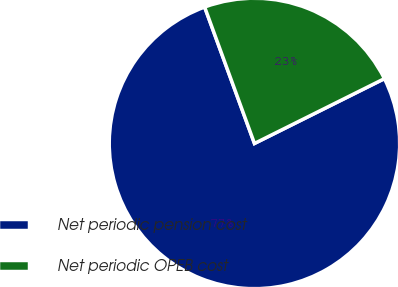Convert chart to OTSL. <chart><loc_0><loc_0><loc_500><loc_500><pie_chart><fcel>Net periodic pension cost<fcel>Net periodic OPEB cost<nl><fcel>76.79%<fcel>23.21%<nl></chart> 